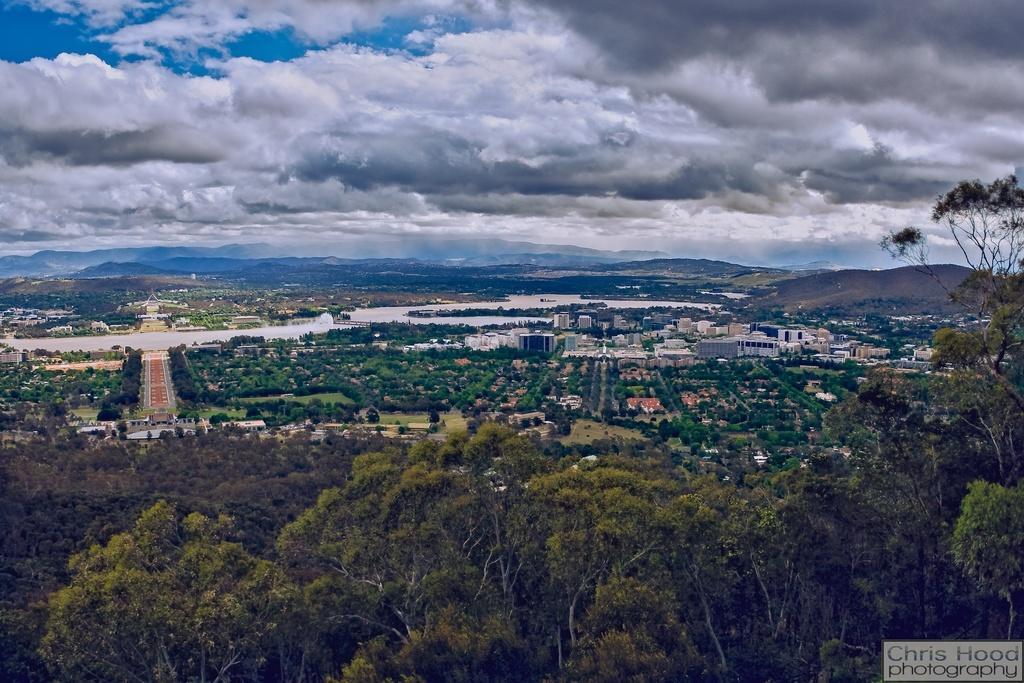Describe this image in one or two sentences. In this image, in the middle there are buildings, trees, grass, hills, text. At the top there are clouds, sky. 